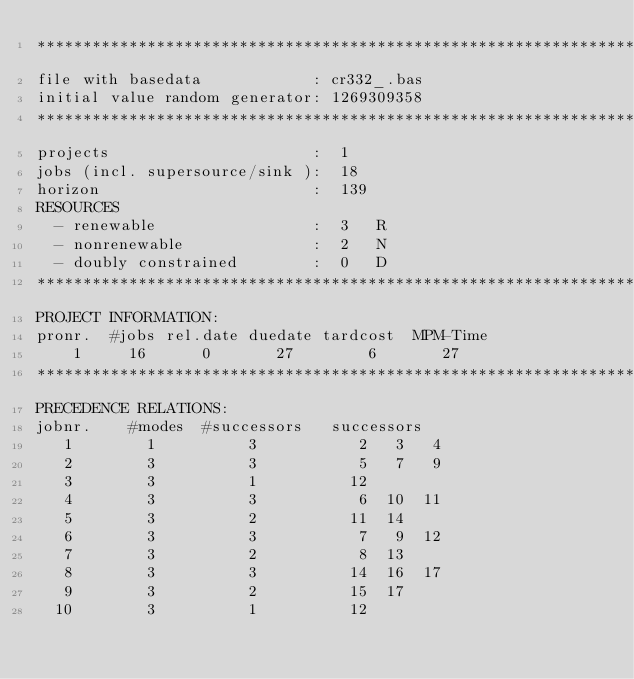<code> <loc_0><loc_0><loc_500><loc_500><_ObjectiveC_>************************************************************************
file with basedata            : cr332_.bas
initial value random generator: 1269309358
************************************************************************
projects                      :  1
jobs (incl. supersource/sink ):  18
horizon                       :  139
RESOURCES
  - renewable                 :  3   R
  - nonrenewable              :  2   N
  - doubly constrained        :  0   D
************************************************************************
PROJECT INFORMATION:
pronr.  #jobs rel.date duedate tardcost  MPM-Time
    1     16      0       27        6       27
************************************************************************
PRECEDENCE RELATIONS:
jobnr.    #modes  #successors   successors
   1        1          3           2   3   4
   2        3          3           5   7   9
   3        3          1          12
   4        3          3           6  10  11
   5        3          2          11  14
   6        3          3           7   9  12
   7        3          2           8  13
   8        3          3          14  16  17
   9        3          2          15  17
  10        3          1          12</code> 